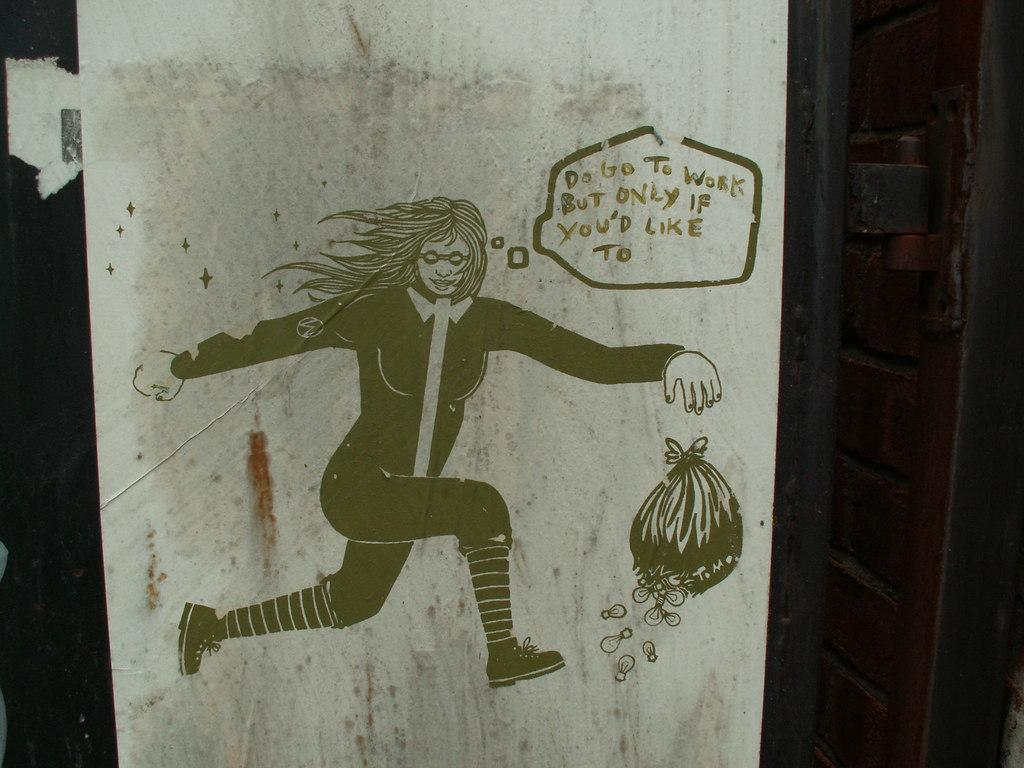What is depicted in the painting in the image? There is a painting of a person in the image. What else can be seen on the wall in the image? There is a bag on the wall in the image. Are there any words or letters in the image? Yes, there is text on the painting or bag in the image. How many wings can be seen on the person in the painting? There are no wings visible on the person in the painting; it is a painting of a person without wings. 